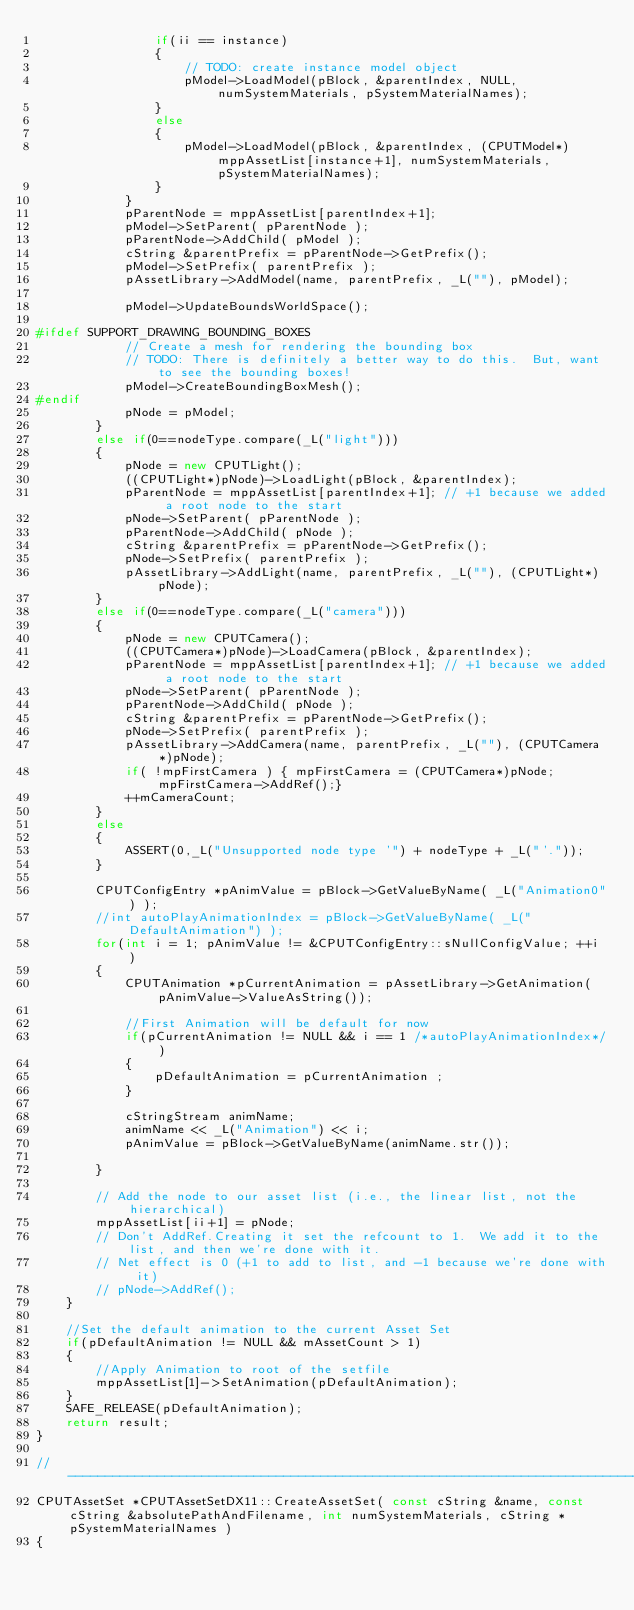Convert code to text. <code><loc_0><loc_0><loc_500><loc_500><_C++_>                if(ii == instance)
                {
                    // TODO: create instance model object
                    pModel->LoadModel(pBlock, &parentIndex, NULL, numSystemMaterials, pSystemMaterialNames);
                }
                else
                {
                    pModel->LoadModel(pBlock, &parentIndex, (CPUTModel*)mppAssetList[instance+1], numSystemMaterials, pSystemMaterialNames);
                }
            }
            pParentNode = mppAssetList[parentIndex+1];
            pModel->SetParent( pParentNode );
            pParentNode->AddChild( pModel );
            cString &parentPrefix = pParentNode->GetPrefix();
            pModel->SetPrefix( parentPrefix );
            pAssetLibrary->AddModel(name, parentPrefix, _L(""), pModel);

            pModel->UpdateBoundsWorldSpace();

#ifdef SUPPORT_DRAWING_BOUNDING_BOXES
            // Create a mesh for rendering the bounding box
            // TODO: There is definitely a better way to do this.  But, want to see the bounding boxes!
            pModel->CreateBoundingBoxMesh();
#endif
            pNode = pModel;
        }
        else if(0==nodeType.compare(_L("light")))
        {
            pNode = new CPUTLight();
            ((CPUTLight*)pNode)->LoadLight(pBlock, &parentIndex);
            pParentNode = mppAssetList[parentIndex+1]; // +1 because we added a root node to the start
            pNode->SetParent( pParentNode );
            pParentNode->AddChild( pNode );
            cString &parentPrefix = pParentNode->GetPrefix();
            pNode->SetPrefix( parentPrefix );
            pAssetLibrary->AddLight(name, parentPrefix, _L(""), (CPUTLight*)pNode);
        }
        else if(0==nodeType.compare(_L("camera")))
        {
            pNode = new CPUTCamera();
            ((CPUTCamera*)pNode)->LoadCamera(pBlock, &parentIndex);
            pParentNode = mppAssetList[parentIndex+1]; // +1 because we added a root node to the start
            pNode->SetParent( pParentNode );
            pParentNode->AddChild( pNode );
            cString &parentPrefix = pParentNode->GetPrefix();
            pNode->SetPrefix( parentPrefix );
            pAssetLibrary->AddCamera(name, parentPrefix, _L(""), (CPUTCamera*)pNode);
            if( !mpFirstCamera ) { mpFirstCamera = (CPUTCamera*)pNode; mpFirstCamera->AddRef();}
            ++mCameraCount;
        }
        else
        {
            ASSERT(0,_L("Unsupported node type '") + nodeType + _L("'."));
        }

        CPUTConfigEntry *pAnimValue = pBlock->GetValueByName( _L("Animation0") );
		//int autoPlayAnimationIndex = pBlock->GetValueByName( _L("DefaultAnimation") );
        for(int i = 1; pAnimValue != &CPUTConfigEntry::sNullConfigValue; ++i )
        {
			CPUTAnimation *pCurrentAnimation = pAssetLibrary->GetAnimation(pAnimValue->ValueAsString());
			
            //First Animation will be default for now
			if(pCurrentAnimation != NULL && i == 1 /*autoPlayAnimationIndex*/)
			{
				pDefaultAnimation = pCurrentAnimation ;
			}

            cStringStream animName;
            animName << _L("Animation") << i;
            pAnimValue = pBlock->GetValueByName(animName.str());

        }

        // Add the node to our asset list (i.e., the linear list, not the hierarchical)
        mppAssetList[ii+1] = pNode;
        // Don't AddRef.Creating it set the refcount to 1.  We add it to the list, and then we're done with it.
        // Net effect is 0 (+1 to add to list, and -1 because we're done with it)
        // pNode->AddRef();
    }

    //Set the default animation to the current Asset Set
	if(pDefaultAnimation != NULL && mAssetCount > 1)
	{
        //Apply Animation to root of the setfile
		mppAssetList[1]->SetAnimation(pDefaultAnimation);
	}
	SAFE_RELEASE(pDefaultAnimation);
    return result;
}

//-----------------------------------------------------------------------------
CPUTAssetSet *CPUTAssetSetDX11::CreateAssetSet( const cString &name, const cString &absolutePathAndFilename, int numSystemMaterials, cString *pSystemMaterialNames )
{</code> 